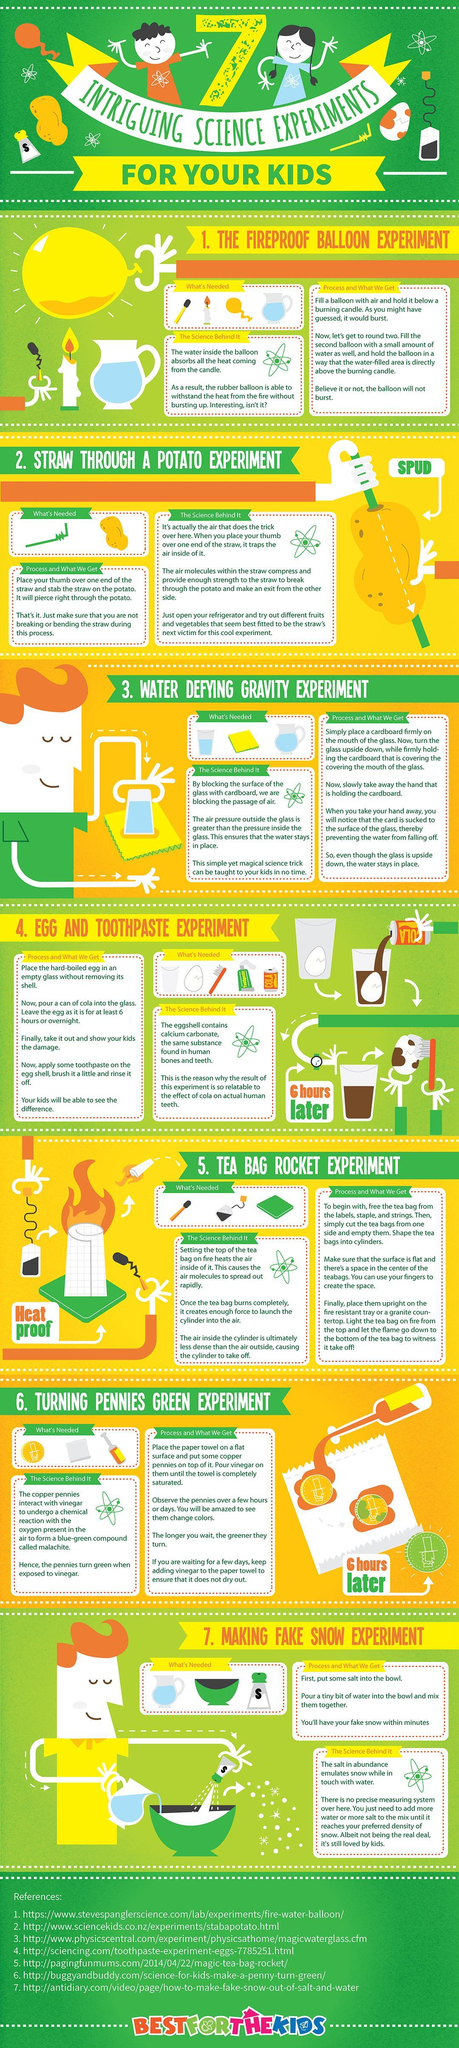What are the things needed for experiment seven?
Answer the question with a short phrase. Water, Bowl, Salt Which experiment requires the most number of things for experimenting, 1, 2, 3, or 4 ? 4 Which drink is needed for the egg and toothpaste experiment? Cola 